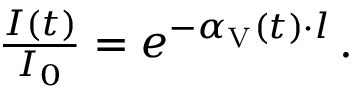Convert formula to latex. <formula><loc_0><loc_0><loc_500><loc_500>\begin{array} { r } { \frac { I ( t ) } { I _ { 0 } } = e ^ { - \alpha _ { V } ( t ) \cdot l } \, . } \end{array}</formula> 